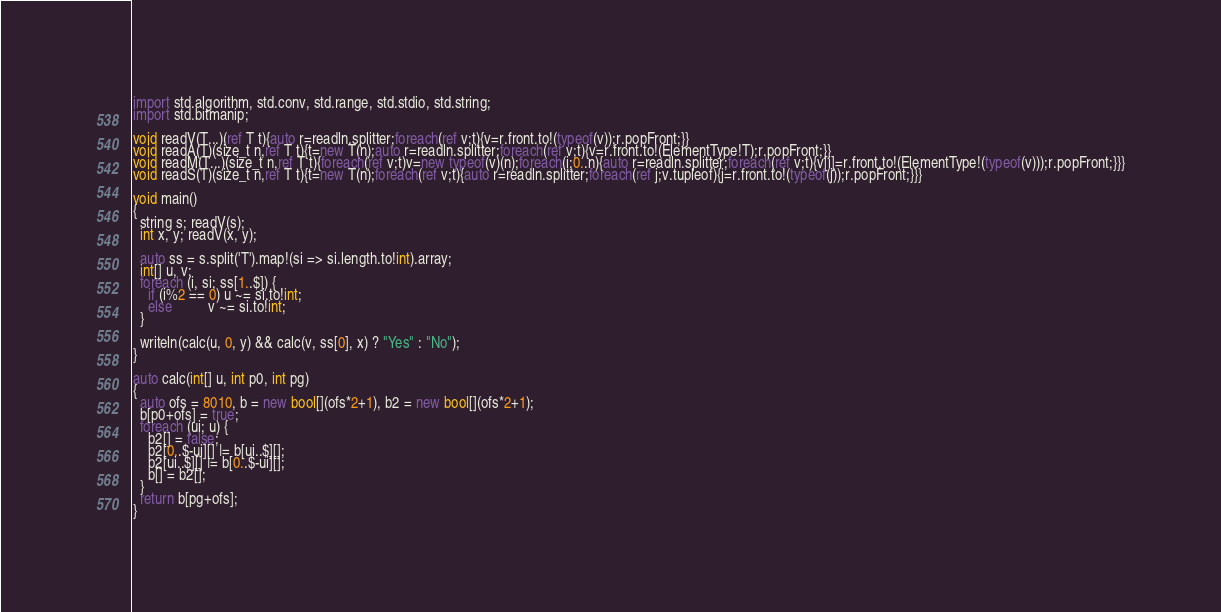Convert code to text. <code><loc_0><loc_0><loc_500><loc_500><_D_>import std.algorithm, std.conv, std.range, std.stdio, std.string;
import std.bitmanip;

void readV(T...)(ref T t){auto r=readln.splitter;foreach(ref v;t){v=r.front.to!(typeof(v));r.popFront;}}
void readA(T)(size_t n,ref T t){t=new T(n);auto r=readln.splitter;foreach(ref v;t){v=r.front.to!(ElementType!T);r.popFront;}}
void readM(T...)(size_t n,ref T t){foreach(ref v;t)v=new typeof(v)(n);foreach(i;0..n){auto r=readln.splitter;foreach(ref v;t){v[i]=r.front.to!(ElementType!(typeof(v)));r.popFront;}}}
void readS(T)(size_t n,ref T t){t=new T(n);foreach(ref v;t){auto r=readln.splitter;foreach(ref j;v.tupleof){j=r.front.to!(typeof(j));r.popFront;}}}

void main()
{
  string s; readV(s);
  int x, y; readV(x, y);

  auto ss = s.split('T').map!(si => si.length.to!int).array;
  int[] u, v;
  foreach (i, si; ss[1..$]) {
    if (i%2 == 0) u ~= si.to!int;
    else          v ~= si.to!int;
  }

  writeln(calc(u, 0, y) && calc(v, ss[0], x) ? "Yes" : "No");
}

auto calc(int[] u, int p0, int pg)
{
  auto ofs = 8010, b = new bool[](ofs*2+1), b2 = new bool[](ofs*2+1);
  b[p0+ofs] = true;
  foreach (ui; u) {
    b2[] = false;
    b2[0..$-ui][] |= b[ui..$][];
    b2[ui..$][] |= b[0..$-ui][];
    b[] = b2[];
  }
  return b[pg+ofs];
}
</code> 